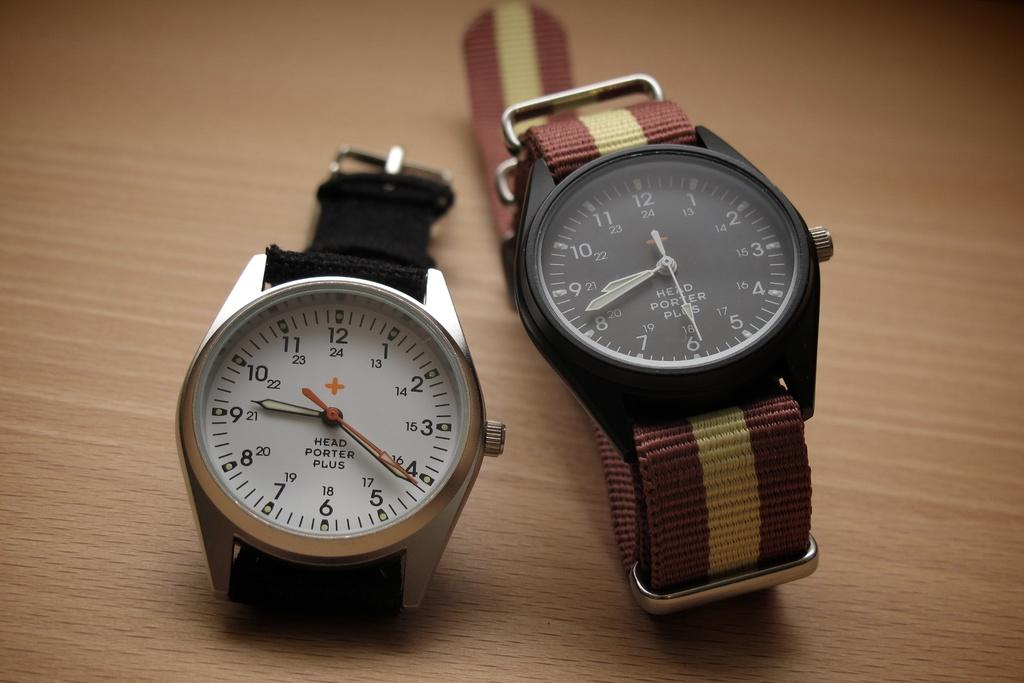<image>
Summarize the visual content of the image. Two watches from Head Porter plus are on the table. 